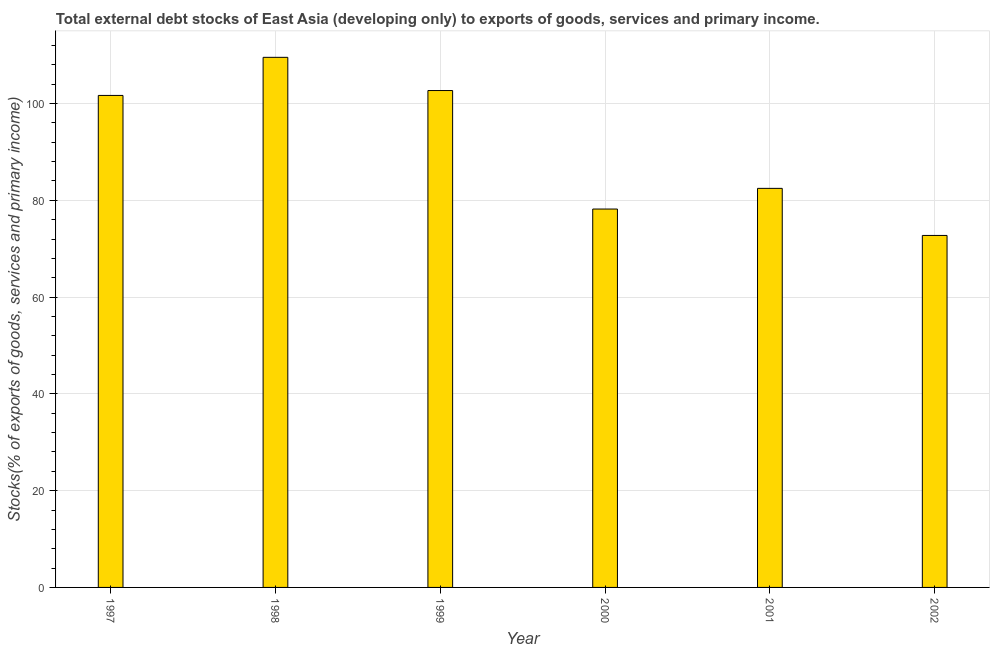Does the graph contain any zero values?
Provide a short and direct response. No. What is the title of the graph?
Make the answer very short. Total external debt stocks of East Asia (developing only) to exports of goods, services and primary income. What is the label or title of the Y-axis?
Keep it short and to the point. Stocks(% of exports of goods, services and primary income). What is the external debt stocks in 1997?
Offer a terse response. 101.67. Across all years, what is the maximum external debt stocks?
Give a very brief answer. 109.55. Across all years, what is the minimum external debt stocks?
Your answer should be very brief. 72.74. In which year was the external debt stocks maximum?
Your answer should be compact. 1998. In which year was the external debt stocks minimum?
Keep it short and to the point. 2002. What is the sum of the external debt stocks?
Your answer should be very brief. 547.3. What is the difference between the external debt stocks in 1997 and 2000?
Your response must be concise. 23.48. What is the average external debt stocks per year?
Make the answer very short. 91.22. What is the median external debt stocks?
Offer a terse response. 92.07. What is the ratio of the external debt stocks in 2000 to that in 2002?
Offer a very short reply. 1.07. Is the external debt stocks in 1999 less than that in 2001?
Your answer should be compact. No. What is the difference between the highest and the second highest external debt stocks?
Ensure brevity in your answer.  6.86. What is the difference between the highest and the lowest external debt stocks?
Offer a very short reply. 36.81. How many bars are there?
Your answer should be compact. 6. How many years are there in the graph?
Keep it short and to the point. 6. What is the Stocks(% of exports of goods, services and primary income) of 1997?
Offer a terse response. 101.67. What is the Stocks(% of exports of goods, services and primary income) of 1998?
Your answer should be very brief. 109.55. What is the Stocks(% of exports of goods, services and primary income) in 1999?
Your response must be concise. 102.68. What is the Stocks(% of exports of goods, services and primary income) in 2000?
Make the answer very short. 78.2. What is the Stocks(% of exports of goods, services and primary income) in 2001?
Give a very brief answer. 82.47. What is the Stocks(% of exports of goods, services and primary income) in 2002?
Keep it short and to the point. 72.74. What is the difference between the Stocks(% of exports of goods, services and primary income) in 1997 and 1998?
Your response must be concise. -7.87. What is the difference between the Stocks(% of exports of goods, services and primary income) in 1997 and 1999?
Make the answer very short. -1.01. What is the difference between the Stocks(% of exports of goods, services and primary income) in 1997 and 2000?
Make the answer very short. 23.48. What is the difference between the Stocks(% of exports of goods, services and primary income) in 1997 and 2001?
Keep it short and to the point. 19.2. What is the difference between the Stocks(% of exports of goods, services and primary income) in 1997 and 2002?
Make the answer very short. 28.93. What is the difference between the Stocks(% of exports of goods, services and primary income) in 1998 and 1999?
Your response must be concise. 6.86. What is the difference between the Stocks(% of exports of goods, services and primary income) in 1998 and 2000?
Provide a succinct answer. 31.35. What is the difference between the Stocks(% of exports of goods, services and primary income) in 1998 and 2001?
Your response must be concise. 27.08. What is the difference between the Stocks(% of exports of goods, services and primary income) in 1998 and 2002?
Make the answer very short. 36.81. What is the difference between the Stocks(% of exports of goods, services and primary income) in 1999 and 2000?
Provide a short and direct response. 24.49. What is the difference between the Stocks(% of exports of goods, services and primary income) in 1999 and 2001?
Provide a succinct answer. 20.22. What is the difference between the Stocks(% of exports of goods, services and primary income) in 1999 and 2002?
Give a very brief answer. 29.94. What is the difference between the Stocks(% of exports of goods, services and primary income) in 2000 and 2001?
Give a very brief answer. -4.27. What is the difference between the Stocks(% of exports of goods, services and primary income) in 2000 and 2002?
Make the answer very short. 5.46. What is the difference between the Stocks(% of exports of goods, services and primary income) in 2001 and 2002?
Provide a short and direct response. 9.73. What is the ratio of the Stocks(% of exports of goods, services and primary income) in 1997 to that in 1998?
Keep it short and to the point. 0.93. What is the ratio of the Stocks(% of exports of goods, services and primary income) in 1997 to that in 1999?
Make the answer very short. 0.99. What is the ratio of the Stocks(% of exports of goods, services and primary income) in 1997 to that in 2001?
Your response must be concise. 1.23. What is the ratio of the Stocks(% of exports of goods, services and primary income) in 1997 to that in 2002?
Your answer should be very brief. 1.4. What is the ratio of the Stocks(% of exports of goods, services and primary income) in 1998 to that in 1999?
Offer a very short reply. 1.07. What is the ratio of the Stocks(% of exports of goods, services and primary income) in 1998 to that in 2000?
Ensure brevity in your answer.  1.4. What is the ratio of the Stocks(% of exports of goods, services and primary income) in 1998 to that in 2001?
Offer a terse response. 1.33. What is the ratio of the Stocks(% of exports of goods, services and primary income) in 1998 to that in 2002?
Your answer should be very brief. 1.51. What is the ratio of the Stocks(% of exports of goods, services and primary income) in 1999 to that in 2000?
Offer a terse response. 1.31. What is the ratio of the Stocks(% of exports of goods, services and primary income) in 1999 to that in 2001?
Provide a succinct answer. 1.25. What is the ratio of the Stocks(% of exports of goods, services and primary income) in 1999 to that in 2002?
Provide a succinct answer. 1.41. What is the ratio of the Stocks(% of exports of goods, services and primary income) in 2000 to that in 2001?
Provide a short and direct response. 0.95. What is the ratio of the Stocks(% of exports of goods, services and primary income) in 2000 to that in 2002?
Keep it short and to the point. 1.07. What is the ratio of the Stocks(% of exports of goods, services and primary income) in 2001 to that in 2002?
Your answer should be compact. 1.13. 